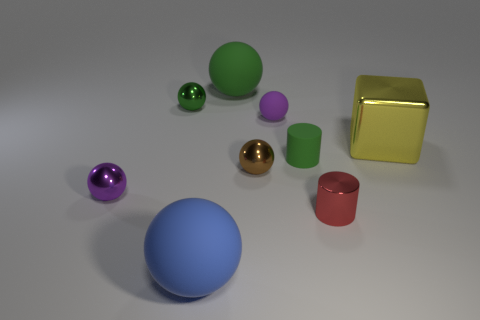Subtract all brown balls. How many balls are left? 5 Subtract all small green metallic balls. How many balls are left? 5 Add 1 tiny purple rubber balls. How many objects exist? 10 Subtract all green spheres. Subtract all red cylinders. How many spheres are left? 4 Subtract all cylinders. How many objects are left? 7 Subtract all big balls. Subtract all big green spheres. How many objects are left? 6 Add 8 small green metallic balls. How many small green metallic balls are left? 9 Add 7 small red metallic objects. How many small red metallic objects exist? 8 Subtract 0 yellow cylinders. How many objects are left? 9 